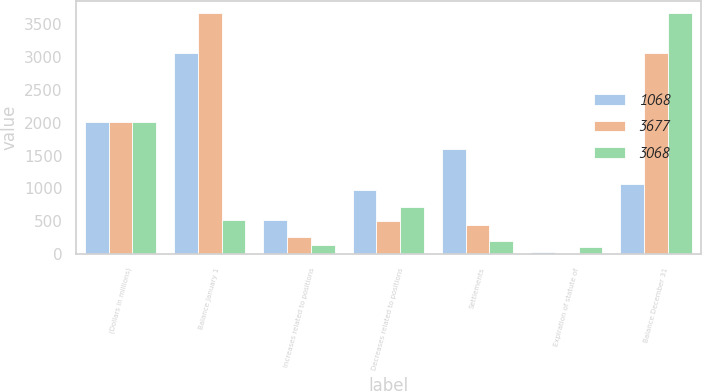Convert chart. <chart><loc_0><loc_0><loc_500><loc_500><stacked_bar_chart><ecel><fcel>(Dollars in millions)<fcel>Balance January 1<fcel>Increases related to positions<fcel>Decreases related to positions<fcel>Settlements<fcel>Expiration of statute of<fcel>Balance December 31<nl><fcel>1068<fcel>2014<fcel>3068<fcel>519<fcel>973<fcel>1594<fcel>27<fcel>1068<nl><fcel>3677<fcel>2013<fcel>3677<fcel>254<fcel>508<fcel>448<fcel>5<fcel>3068<nl><fcel>3068<fcel>2012<fcel>519<fcel>142<fcel>711<fcel>205<fcel>104<fcel>3677<nl></chart> 